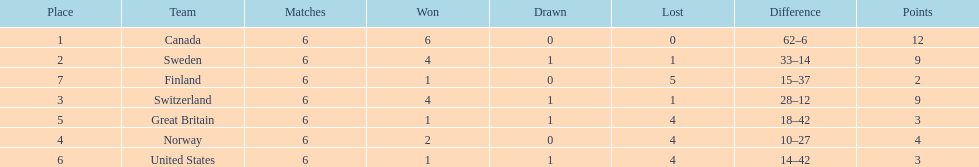Which country conceded the least goals? Finland. 